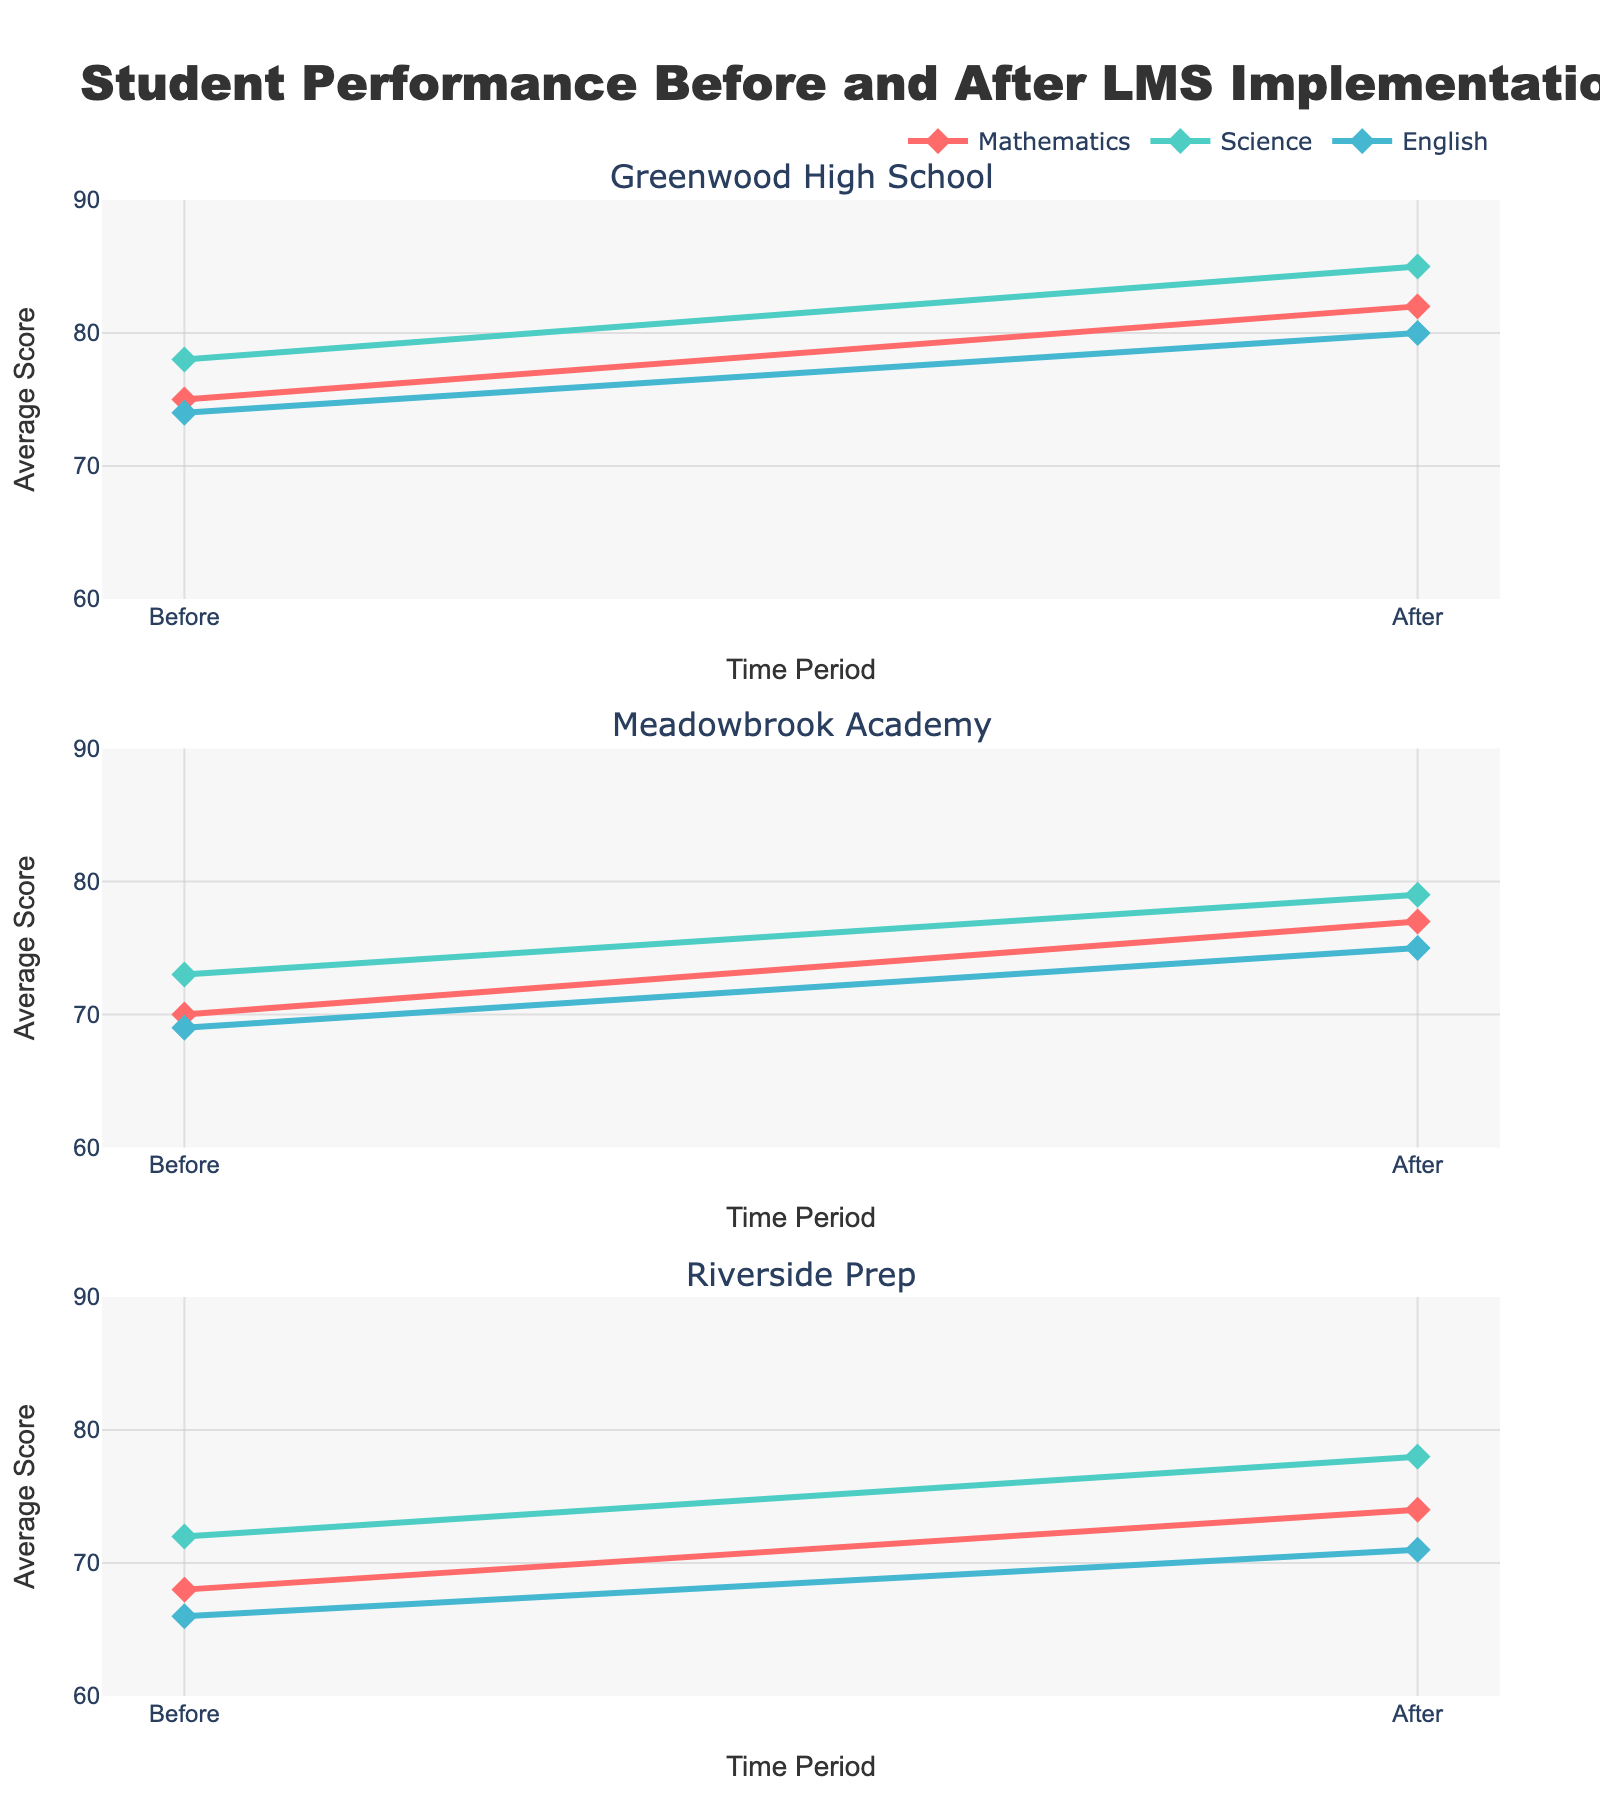What is the overall trend in student performance before and after implementing the Learning Management System (LMS)? The overall trend shows an increase in the average scores for all subjects and schools after the LMS implementation, indicating improvement in student performance.
Answer: Improvement Which subject improved the most at Greenwood High School after LMS implementation? At Greenwood High School, Science improved from 78 to 85, which is an increase of 7 points, the most compared to Mathematics (7 points) and English (6 points).
Answer: Science How do the score improvements in Mathematics compare between Greenwood High School and Meadowbrook Academy? Greenwood High School's Mathematics scores improved by 7 points (from 75 to 82), while Meadowbrook Academy's improved by 7 points (from 70 to 77).
Answer: Equal What is the average score improvement for all subjects combined at Riverside Prep? Riverside Prep saw improvements of 6 points in Mathematics (from 68 to 74), Science (from 72 to 78), and English (from 66 to 71). Averaging these improvements: (6 + 6 + 5) / 3 = 5.67.
Answer: 5.67 Which school showed the smallest improvement in English? Meadowbrook Academy improved in English from 69 to 75, an increase of 6 points, which is the smallest compared to Greenwood High School (6 points) and Riverside Prep (5 points).
Answer: Riverside Prep Compare the total score before and after LMS implementation at Riverside Prep. Riverside Prep had total scores of 68+72+66 = 206 before and 74+78+71 = 223 after. The difference is 223 - 206 = 17 points.
Answer: 17 Which school had the largest overall increase in average scores across all subjects? Greenwood High School had improvements of 7 (Mathematics), 7 (Science), and 6 (English) points, totaling 20 points. Meadowbrook Academy had a total of 6 + 6 + 6 = 18 points. Riverside Prep had 6 + 6 + 5 = 17 points. So, Greenwood High had the largest increase.
Answer: Greenwood High School In which subject did Riverside Prep students show the smallest improvement, and by how many points? Riverside Prep students showed the smallest improvement in English with an increase of 5 points (from 66 to 71).
Answer: English, 5 points 